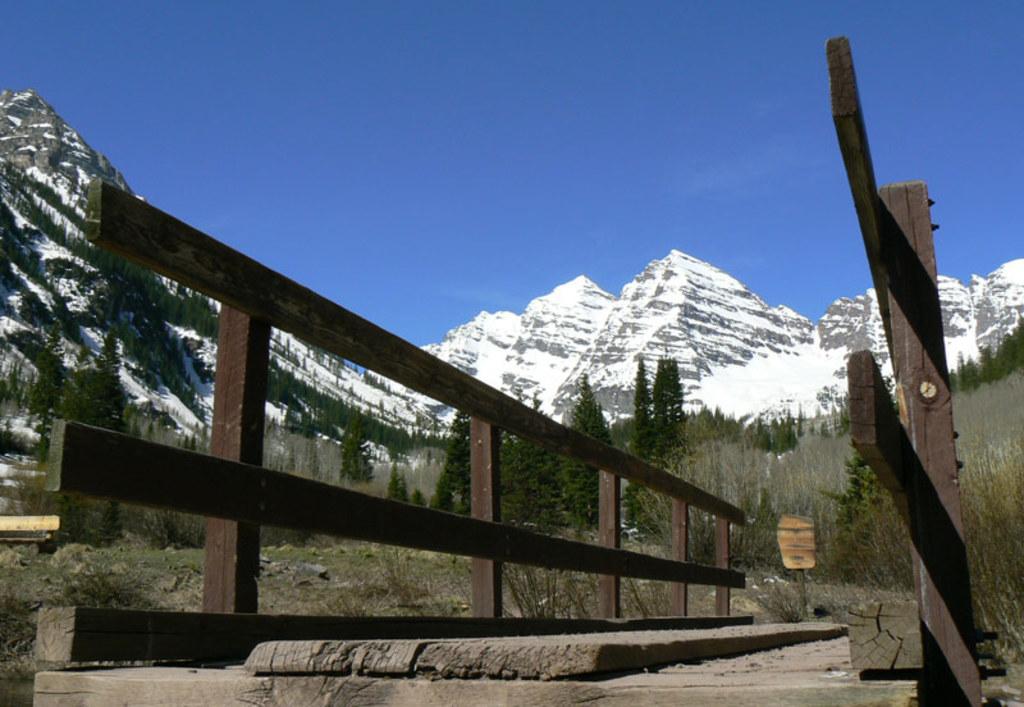Can you describe this image briefly? This picture shows wooden bridge and we see trees, plants and grass on the ground and we see a blue sky and hills. 